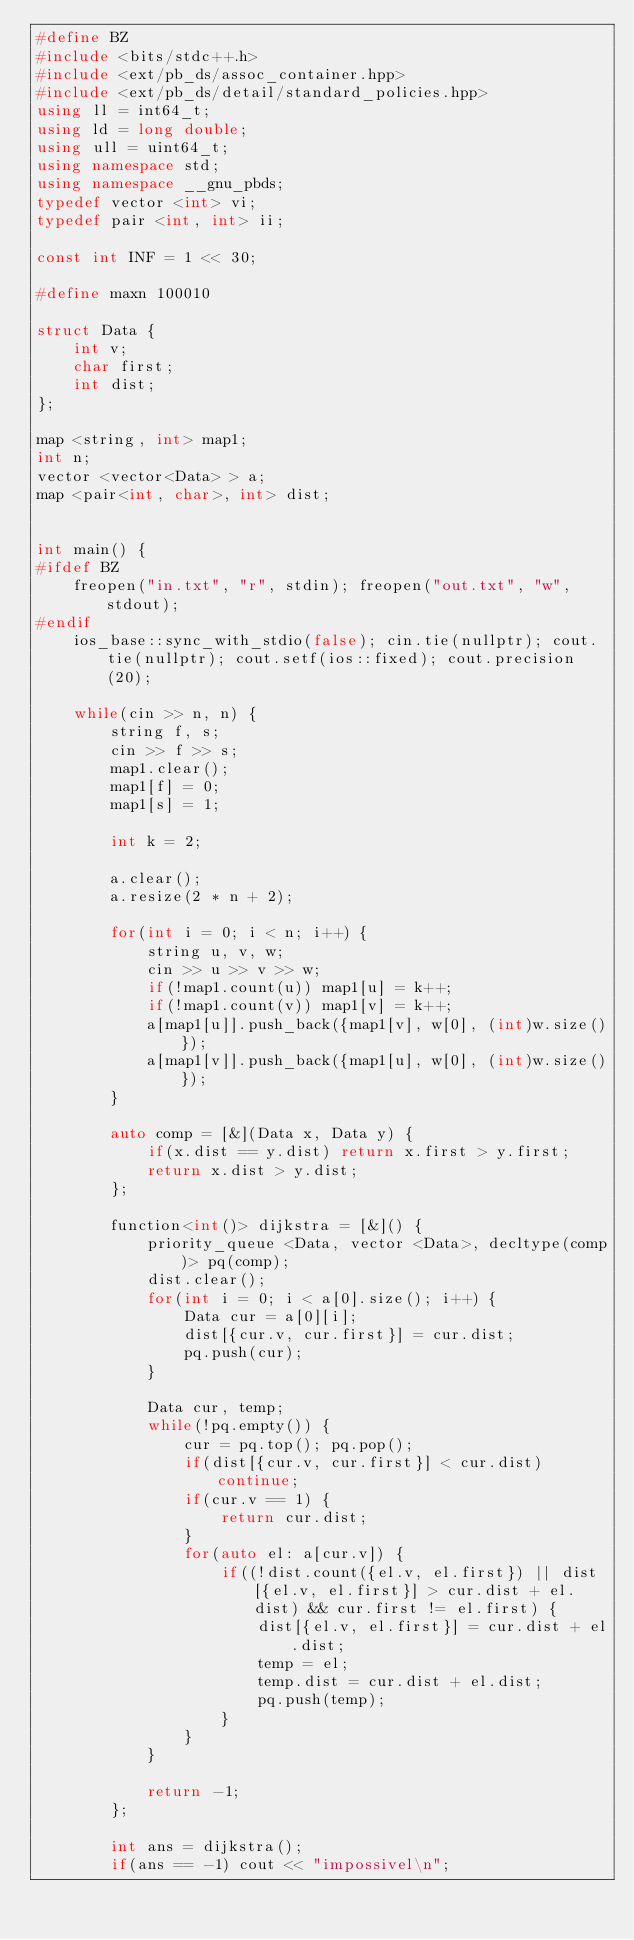Convert code to text. <code><loc_0><loc_0><loc_500><loc_500><_C++_>#define BZ
#include <bits/stdc++.h>
#include <ext/pb_ds/assoc_container.hpp>
#include <ext/pb_ds/detail/standard_policies.hpp>
using ll = int64_t;
using ld = long double;
using ull = uint64_t;
using namespace std;
using namespace __gnu_pbds;
typedef vector <int> vi;
typedef pair <int, int> ii;

const int INF = 1 << 30;

#define maxn 100010

struct Data {
    int v;
    char first;
    int dist;
};

map <string, int> map1;
int n;
vector <vector<Data> > a;
map <pair<int, char>, int> dist;


int main() {
#ifdef BZ
    freopen("in.txt", "r", stdin); freopen("out.txt", "w", stdout);
#endif
    ios_base::sync_with_stdio(false); cin.tie(nullptr); cout.tie(nullptr); cout.setf(ios::fixed); cout.precision(20);

    while(cin >> n, n) {
        string f, s;
        cin >> f >> s;
        map1.clear();
        map1[f] = 0;
        map1[s] = 1;

        int k = 2;

        a.clear();
        a.resize(2 * n + 2);

        for(int i = 0; i < n; i++) {
            string u, v, w;
            cin >> u >> v >> w;
            if(!map1.count(u)) map1[u] = k++;
            if(!map1.count(v)) map1[v] = k++;
            a[map1[u]].push_back({map1[v], w[0], (int)w.size()});
            a[map1[v]].push_back({map1[u], w[0], (int)w.size()});
        }

        auto comp = [&](Data x, Data y) {
            if(x.dist == y.dist) return x.first > y.first;
            return x.dist > y.dist;
        };

        function<int()> dijkstra = [&]() {
            priority_queue <Data, vector <Data>, decltype(comp)> pq(comp);
            dist.clear();
            for(int i = 0; i < a[0].size(); i++) {
                Data cur = a[0][i];
                dist[{cur.v, cur.first}] = cur.dist;
                pq.push(cur);
            }

            Data cur, temp;
            while(!pq.empty()) {
                cur = pq.top(); pq.pop();
                if(dist[{cur.v, cur.first}] < cur.dist) continue;
                if(cur.v == 1) {
                    return cur.dist;
                }
                for(auto el: a[cur.v]) {
                    if((!dist.count({el.v, el.first}) || dist[{el.v, el.first}] > cur.dist + el.dist) && cur.first != el.first) {
                        dist[{el.v, el.first}] = cur.dist + el.dist;
                        temp = el;
                        temp.dist = cur.dist + el.dist;
                        pq.push(temp);
                    }
                }
            }

            return -1;
        };

        int ans = dijkstra();
        if(ans == -1) cout << "impossivel\n";</code> 